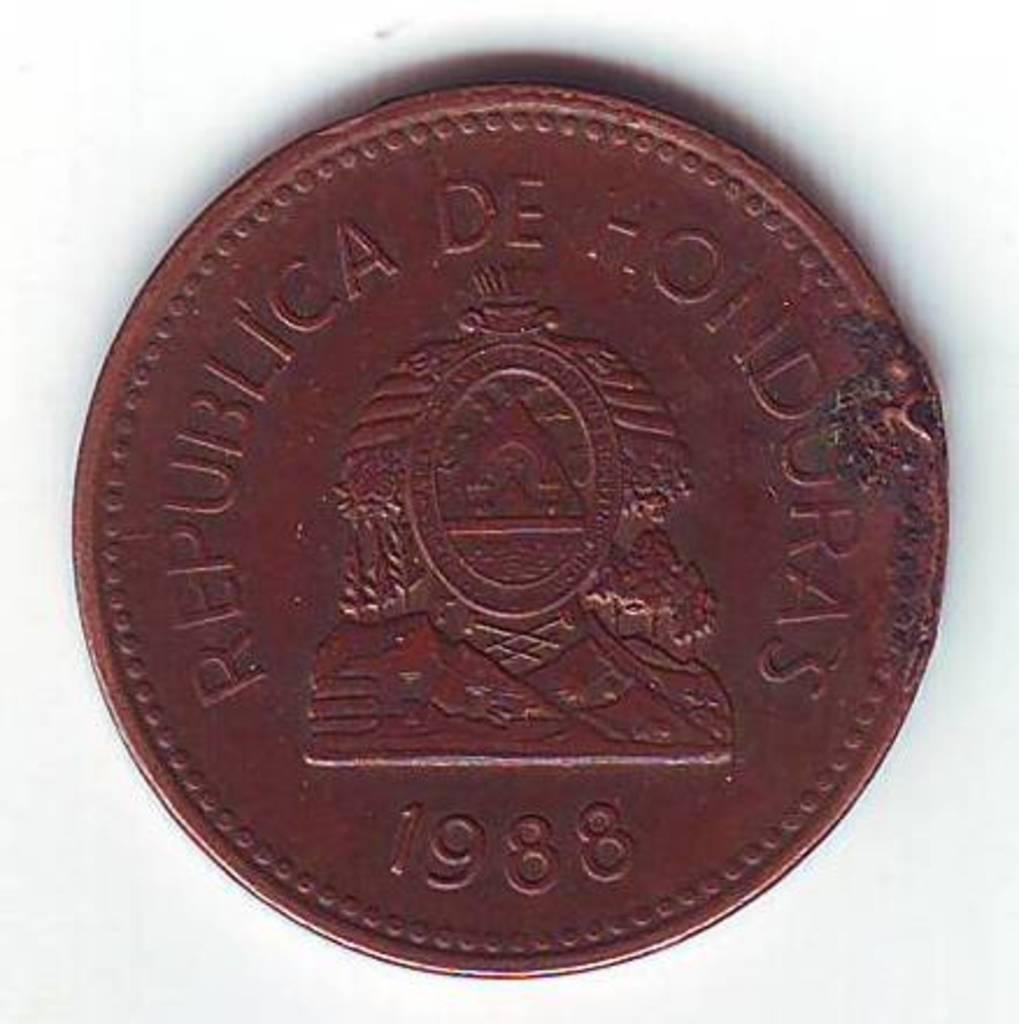Provide a one-sentence caption for the provided image. A dark coin labeled Republica de Hondorus 1988 is laying on a white background. 